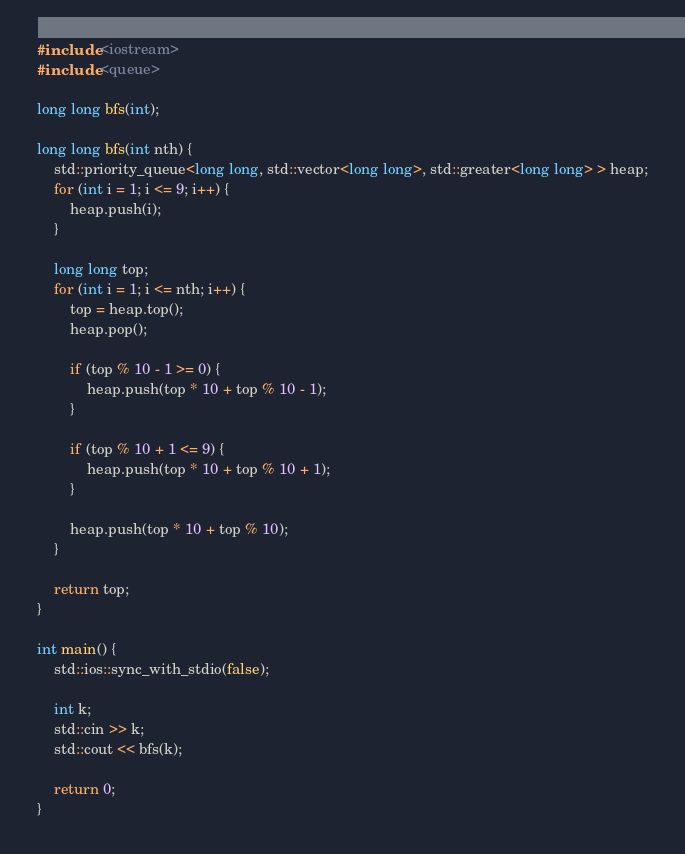Convert code to text. <code><loc_0><loc_0><loc_500><loc_500><_C++_>#include <iostream>
#include <queue>

long long bfs(int);

long long bfs(int nth) {
	std::priority_queue<long long, std::vector<long long>, std::greater<long long> > heap;
	for (int i = 1; i <= 9; i++) {
		heap.push(i);
	}

	long long top;
	for (int i = 1; i <= nth; i++) {
		top = heap.top();
		heap.pop();
		
		if (top % 10 - 1 >= 0) {
			heap.push(top * 10 + top % 10 - 1);
		}
		
		if (top % 10 + 1 <= 9) {
			heap.push(top * 10 + top % 10 + 1);
		}

		heap.push(top * 10 + top % 10);
	}

	return top;
}

int main() {
	std::ios::sync_with_stdio(false);

	int k;
	std::cin >> k;
	std::cout << bfs(k);

	return 0;
}</code> 